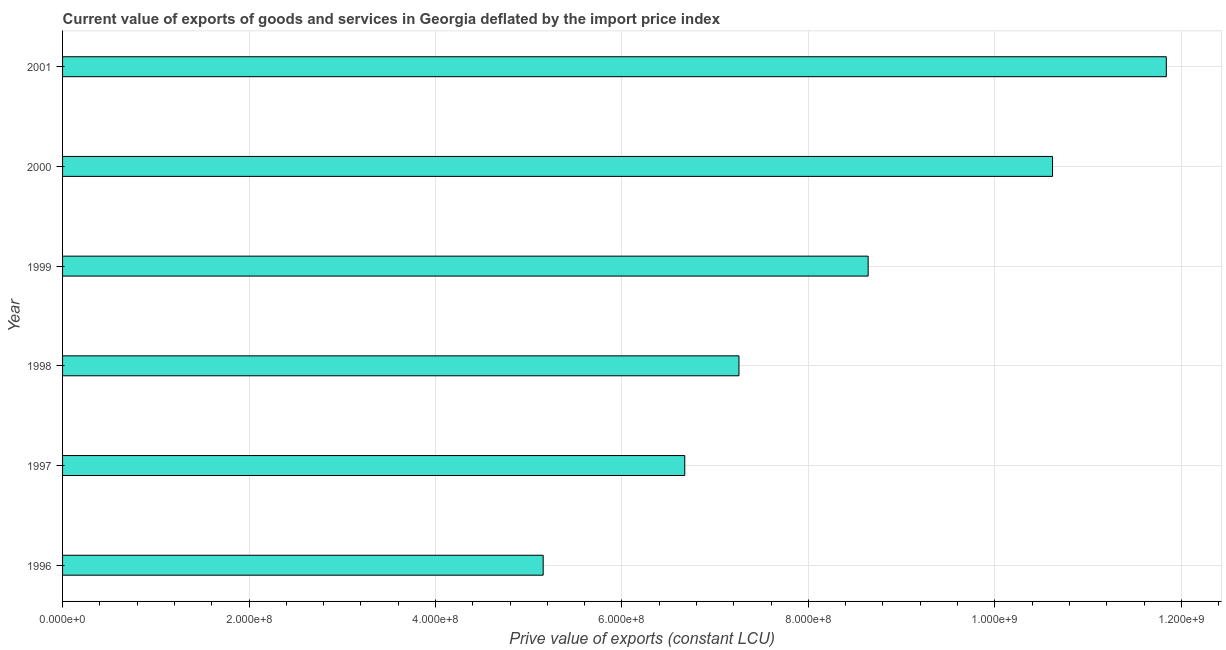Does the graph contain grids?
Keep it short and to the point. Yes. What is the title of the graph?
Make the answer very short. Current value of exports of goods and services in Georgia deflated by the import price index. What is the label or title of the X-axis?
Make the answer very short. Prive value of exports (constant LCU). What is the price value of exports in 1996?
Provide a succinct answer. 5.16e+08. Across all years, what is the maximum price value of exports?
Your answer should be compact. 1.18e+09. Across all years, what is the minimum price value of exports?
Your answer should be compact. 5.16e+08. In which year was the price value of exports minimum?
Make the answer very short. 1996. What is the sum of the price value of exports?
Your answer should be very brief. 5.02e+09. What is the difference between the price value of exports in 1996 and 2001?
Provide a succinct answer. -6.68e+08. What is the average price value of exports per year?
Provide a succinct answer. 8.36e+08. What is the median price value of exports?
Ensure brevity in your answer.  7.95e+08. Do a majority of the years between 1998 and 1997 (inclusive) have price value of exports greater than 280000000 LCU?
Provide a succinct answer. No. What is the ratio of the price value of exports in 1997 to that in 1999?
Your response must be concise. 0.77. Is the price value of exports in 1996 less than that in 2001?
Your answer should be compact. Yes. Is the difference between the price value of exports in 1996 and 1997 greater than the difference between any two years?
Offer a terse response. No. What is the difference between the highest and the second highest price value of exports?
Your answer should be very brief. 1.22e+08. Is the sum of the price value of exports in 1998 and 1999 greater than the maximum price value of exports across all years?
Your answer should be very brief. Yes. What is the difference between the highest and the lowest price value of exports?
Ensure brevity in your answer.  6.68e+08. What is the difference between two consecutive major ticks on the X-axis?
Ensure brevity in your answer.  2.00e+08. What is the Prive value of exports (constant LCU) of 1996?
Give a very brief answer. 5.16e+08. What is the Prive value of exports (constant LCU) in 1997?
Ensure brevity in your answer.  6.67e+08. What is the Prive value of exports (constant LCU) in 1998?
Give a very brief answer. 7.26e+08. What is the Prive value of exports (constant LCU) of 1999?
Offer a terse response. 8.64e+08. What is the Prive value of exports (constant LCU) in 2000?
Provide a succinct answer. 1.06e+09. What is the Prive value of exports (constant LCU) of 2001?
Keep it short and to the point. 1.18e+09. What is the difference between the Prive value of exports (constant LCU) in 1996 and 1997?
Your response must be concise. -1.52e+08. What is the difference between the Prive value of exports (constant LCU) in 1996 and 1998?
Offer a very short reply. -2.10e+08. What is the difference between the Prive value of exports (constant LCU) in 1996 and 1999?
Make the answer very short. -3.49e+08. What is the difference between the Prive value of exports (constant LCU) in 1996 and 2000?
Keep it short and to the point. -5.46e+08. What is the difference between the Prive value of exports (constant LCU) in 1996 and 2001?
Keep it short and to the point. -6.68e+08. What is the difference between the Prive value of exports (constant LCU) in 1997 and 1998?
Your answer should be very brief. -5.81e+07. What is the difference between the Prive value of exports (constant LCU) in 1997 and 1999?
Give a very brief answer. -1.97e+08. What is the difference between the Prive value of exports (constant LCU) in 1997 and 2000?
Offer a terse response. -3.94e+08. What is the difference between the Prive value of exports (constant LCU) in 1997 and 2001?
Offer a terse response. -5.17e+08. What is the difference between the Prive value of exports (constant LCU) in 1998 and 1999?
Your response must be concise. -1.39e+08. What is the difference between the Prive value of exports (constant LCU) in 1998 and 2000?
Your answer should be compact. -3.36e+08. What is the difference between the Prive value of exports (constant LCU) in 1998 and 2001?
Give a very brief answer. -4.58e+08. What is the difference between the Prive value of exports (constant LCU) in 1999 and 2000?
Your answer should be compact. -1.98e+08. What is the difference between the Prive value of exports (constant LCU) in 1999 and 2001?
Ensure brevity in your answer.  -3.20e+08. What is the difference between the Prive value of exports (constant LCU) in 2000 and 2001?
Offer a very short reply. -1.22e+08. What is the ratio of the Prive value of exports (constant LCU) in 1996 to that in 1997?
Offer a terse response. 0.77. What is the ratio of the Prive value of exports (constant LCU) in 1996 to that in 1998?
Provide a short and direct response. 0.71. What is the ratio of the Prive value of exports (constant LCU) in 1996 to that in 1999?
Keep it short and to the point. 0.6. What is the ratio of the Prive value of exports (constant LCU) in 1996 to that in 2000?
Ensure brevity in your answer.  0.48. What is the ratio of the Prive value of exports (constant LCU) in 1996 to that in 2001?
Offer a very short reply. 0.43. What is the ratio of the Prive value of exports (constant LCU) in 1997 to that in 1999?
Give a very brief answer. 0.77. What is the ratio of the Prive value of exports (constant LCU) in 1997 to that in 2000?
Your answer should be compact. 0.63. What is the ratio of the Prive value of exports (constant LCU) in 1997 to that in 2001?
Provide a short and direct response. 0.56. What is the ratio of the Prive value of exports (constant LCU) in 1998 to that in 1999?
Make the answer very short. 0.84. What is the ratio of the Prive value of exports (constant LCU) in 1998 to that in 2000?
Offer a very short reply. 0.68. What is the ratio of the Prive value of exports (constant LCU) in 1998 to that in 2001?
Provide a short and direct response. 0.61. What is the ratio of the Prive value of exports (constant LCU) in 1999 to that in 2000?
Provide a short and direct response. 0.81. What is the ratio of the Prive value of exports (constant LCU) in 1999 to that in 2001?
Offer a terse response. 0.73. What is the ratio of the Prive value of exports (constant LCU) in 2000 to that in 2001?
Your answer should be compact. 0.9. 